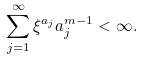<formula> <loc_0><loc_0><loc_500><loc_500>\sum _ { j = 1 } ^ { \infty } \xi ^ { a _ { j } } a ^ { m - 1 } _ { j } < \infty .</formula> 